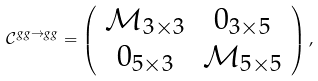Convert formula to latex. <formula><loc_0><loc_0><loc_500><loc_500>\mathcal { C } ^ { g g \rightarrow g g } = \left ( \begin{array} [ c ] { c c } \mathcal { M } _ { 3 \times 3 } & 0 _ { 3 \times 5 } \\ 0 _ { 5 \times 3 } & \mathcal { M } _ { 5 \times 5 } \end{array} \right ) ,</formula> 